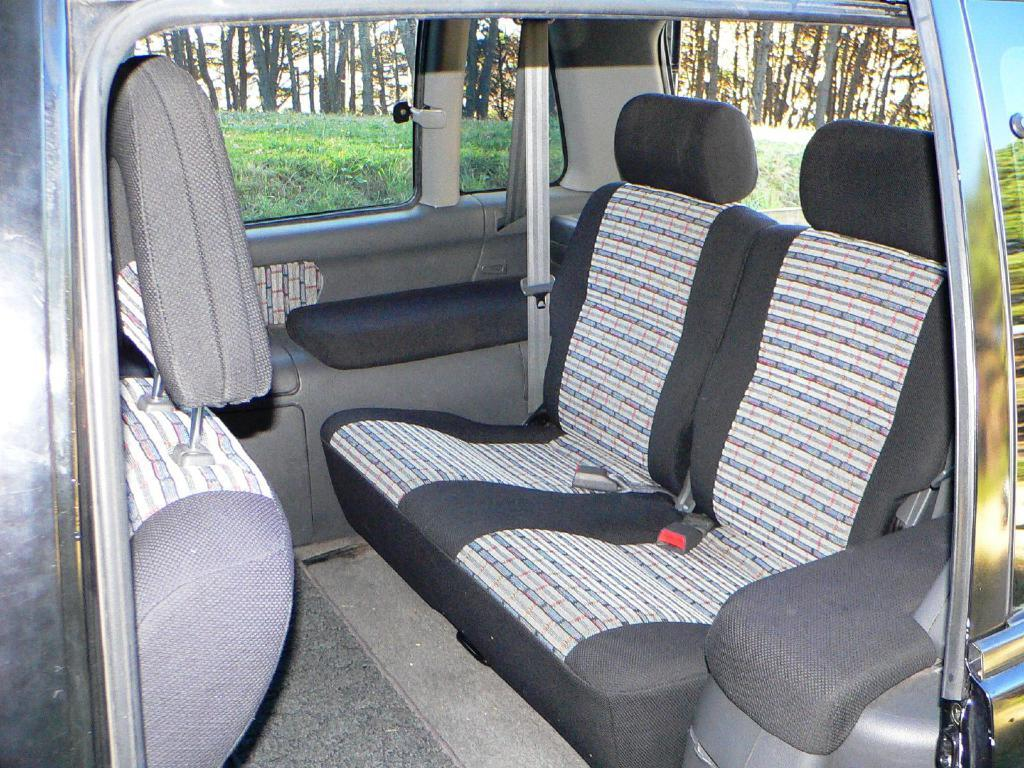What is the setting of the image? The image shows the interior of a car. What can be found inside the car? There are seats and seat belts present in the car. What is visible through the car window? Grass and trees are visible outside the car window. What type of pot can be seen on the dashboard of the car? There is no pot present on the dashboard of the car in the image. 